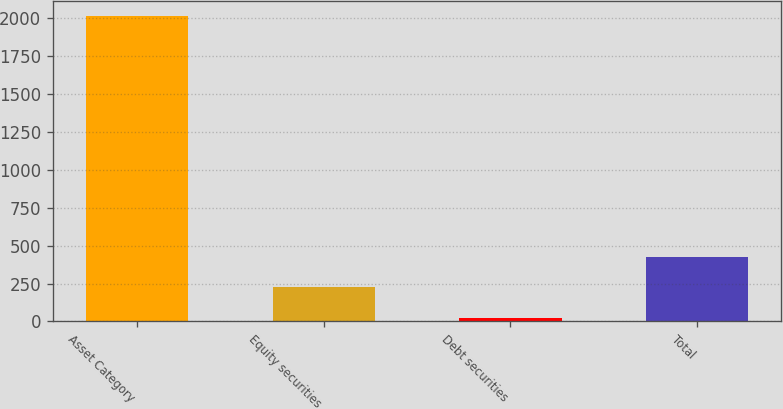Convert chart to OTSL. <chart><loc_0><loc_0><loc_500><loc_500><bar_chart><fcel>Asset Category<fcel>Equity securities<fcel>Debt securities<fcel>Total<nl><fcel>2016<fcel>224.05<fcel>24.94<fcel>423.16<nl></chart> 